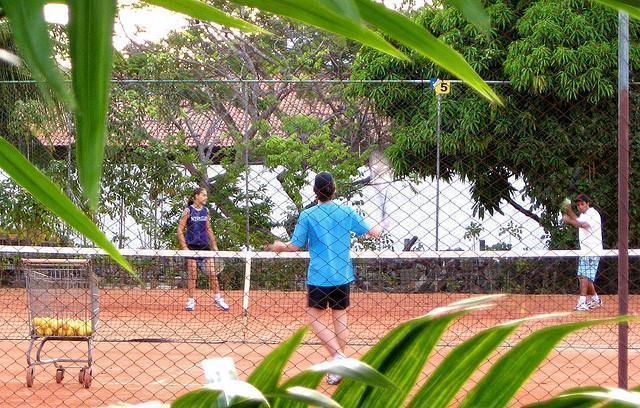What are the tennis balls in the cart for?
Choose the correct response and explain in the format: 'Answer: answer
Rationale: rationale.'
Options: Selling, training, playing, gifting. Answer: training.
Rationale: There are several tennis balls in the cart. 